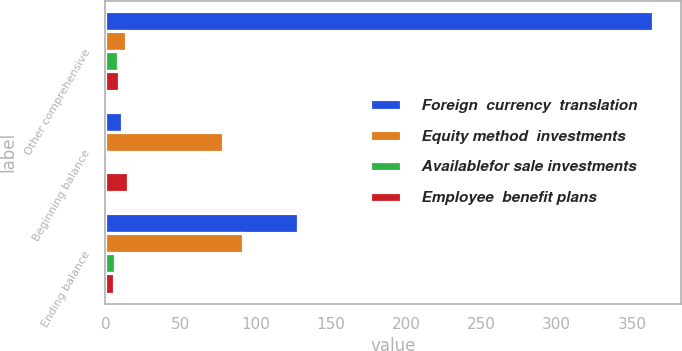<chart> <loc_0><loc_0><loc_500><loc_500><stacked_bar_chart><ecel><fcel>Other comprehensive<fcel>Beginning balance<fcel>Ending balance<nl><fcel>Foreign  currency  translation<fcel>364.4<fcel>11<fcel>128.1<nl><fcel>Equity method  investments<fcel>13.8<fcel>77.9<fcel>91.7<nl><fcel>Availablefor sale investments<fcel>8.3<fcel>1.8<fcel>6.5<nl><fcel>Employee  benefit plans<fcel>9.2<fcel>15.1<fcel>5.9<nl></chart> 